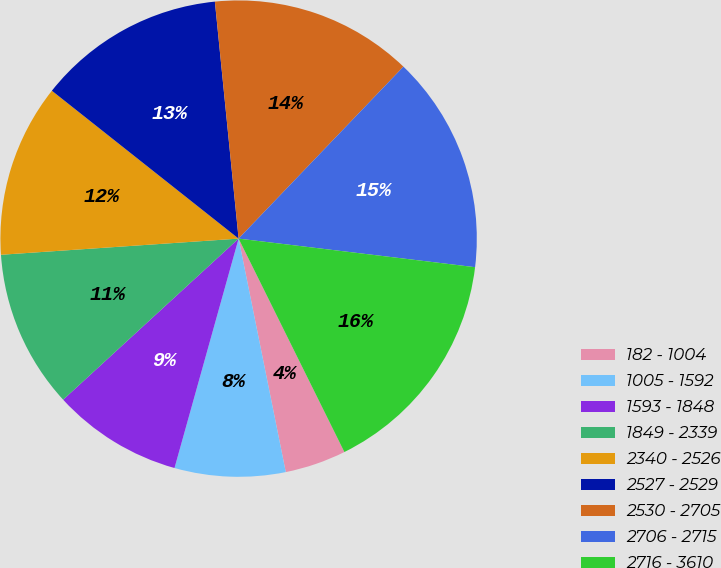Convert chart to OTSL. <chart><loc_0><loc_0><loc_500><loc_500><pie_chart><fcel>182 - 1004<fcel>1005 - 1592<fcel>1593 - 1848<fcel>1849 - 2339<fcel>2340 - 2526<fcel>2527 - 2529<fcel>2530 - 2705<fcel>2706 - 2715<fcel>2716 - 3610<nl><fcel>4.15%<fcel>7.51%<fcel>8.84%<fcel>10.74%<fcel>11.74%<fcel>12.75%<fcel>13.75%<fcel>14.75%<fcel>15.76%<nl></chart> 